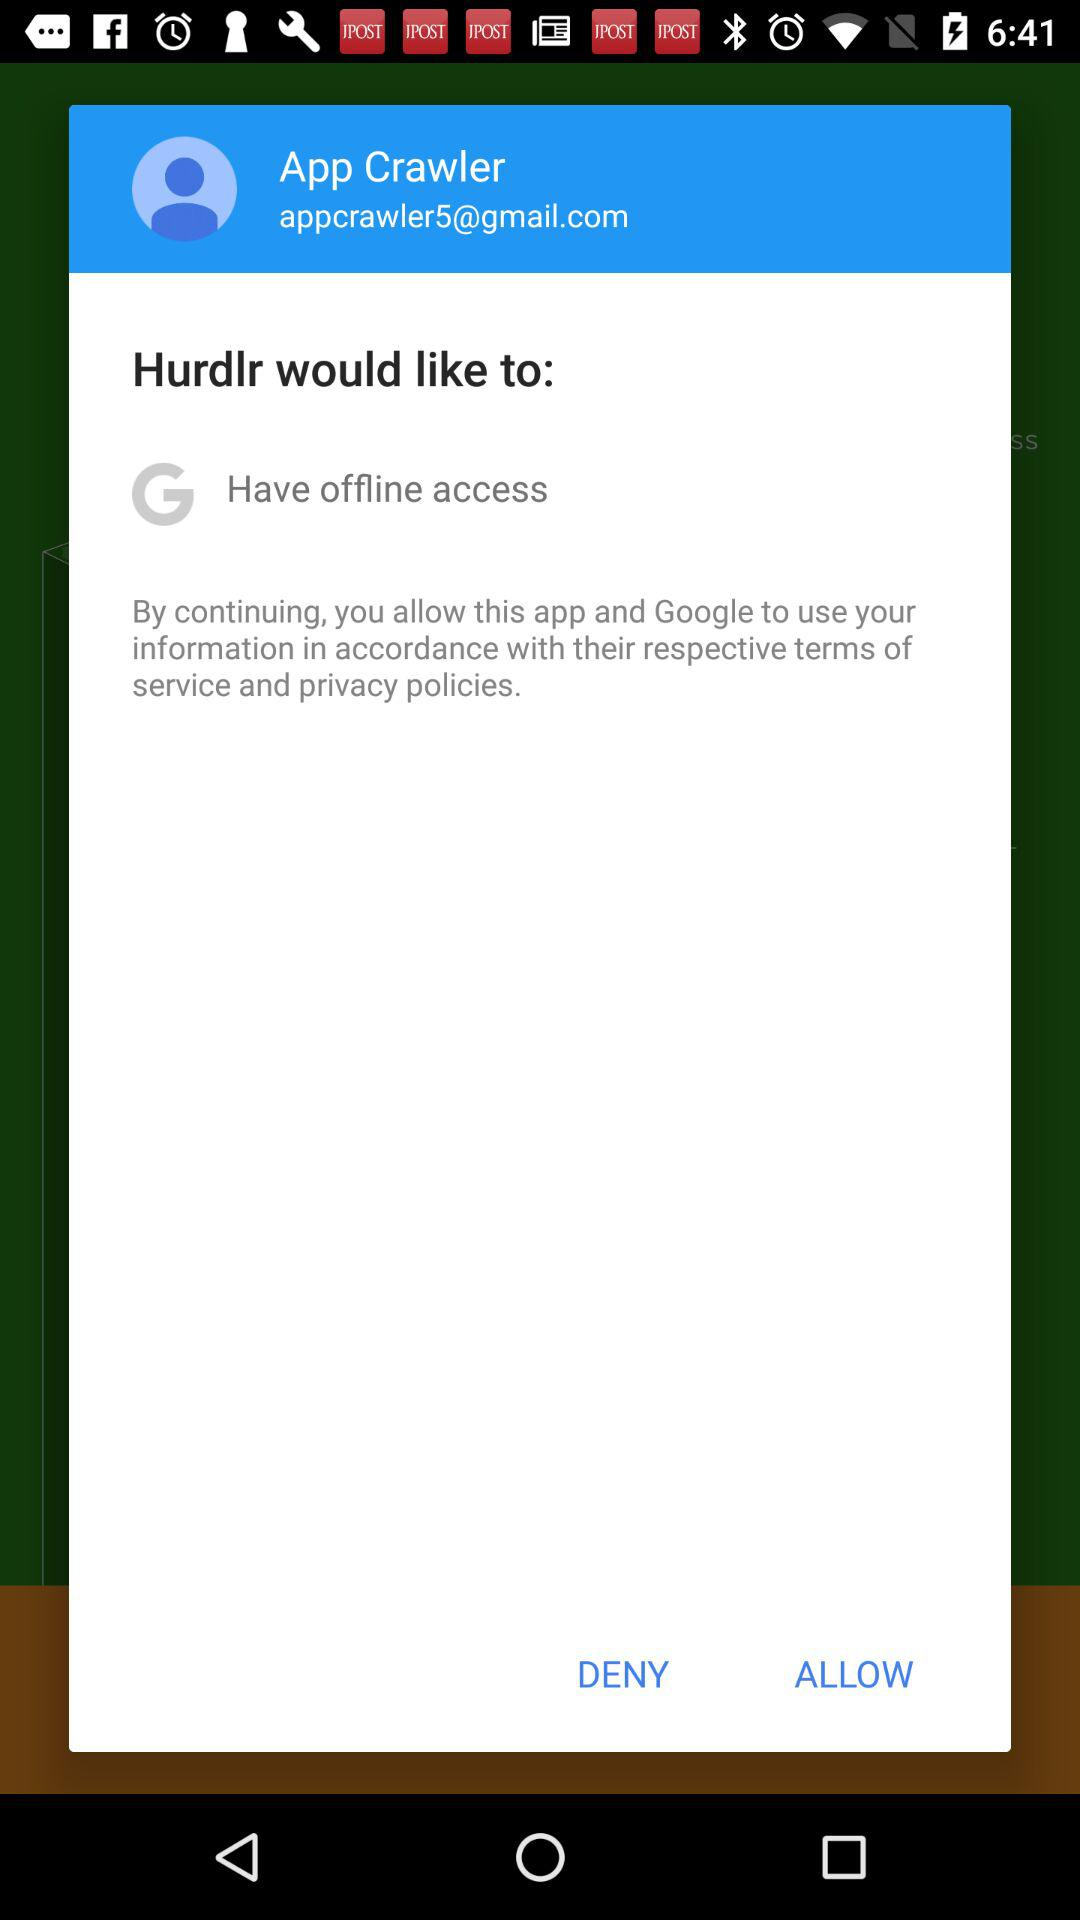What is the name of the user? The name of the user is App Crawler. 